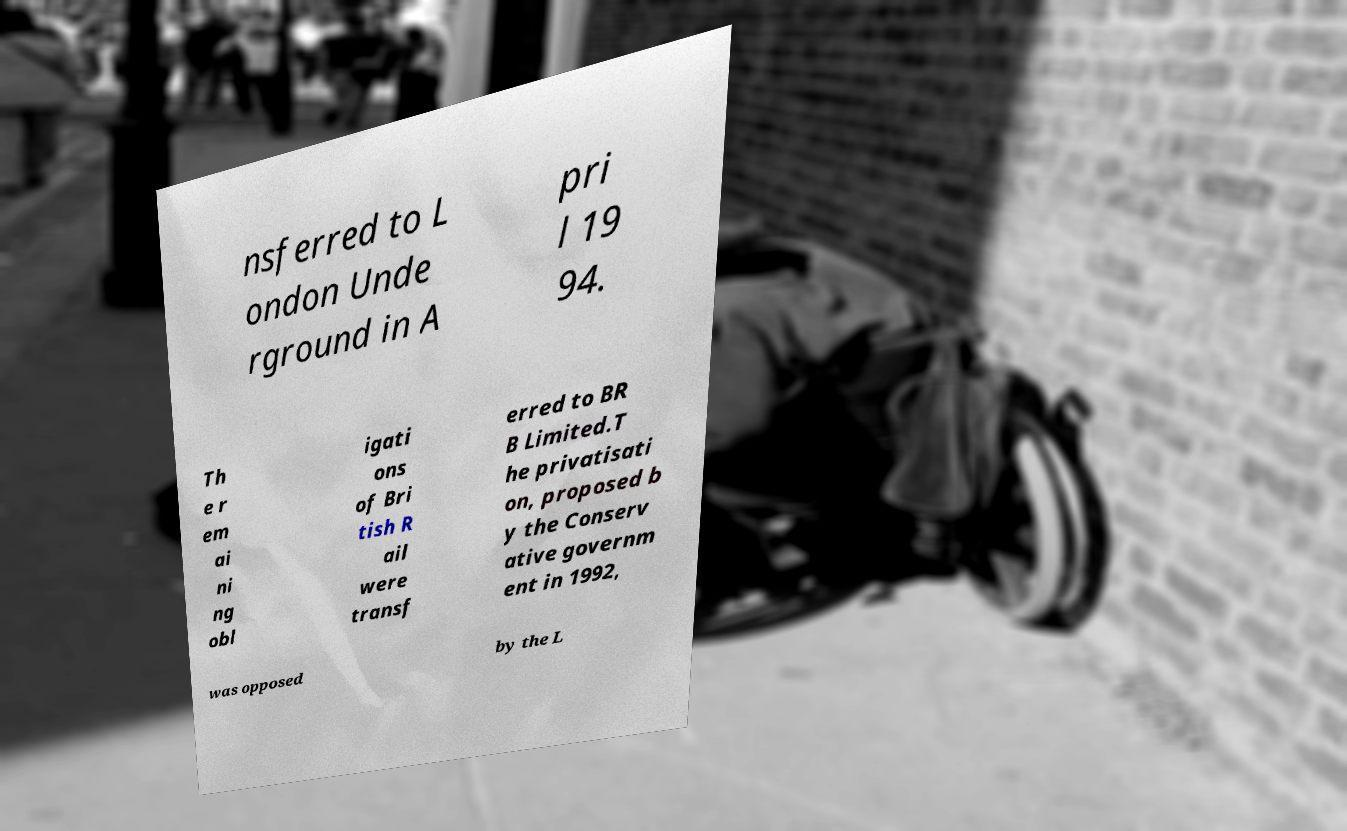There's text embedded in this image that I need extracted. Can you transcribe it verbatim? nsferred to L ondon Unde rground in A pri l 19 94. Th e r em ai ni ng obl igati ons of Bri tish R ail were transf erred to BR B Limited.T he privatisati on, proposed b y the Conserv ative governm ent in 1992, was opposed by the L 